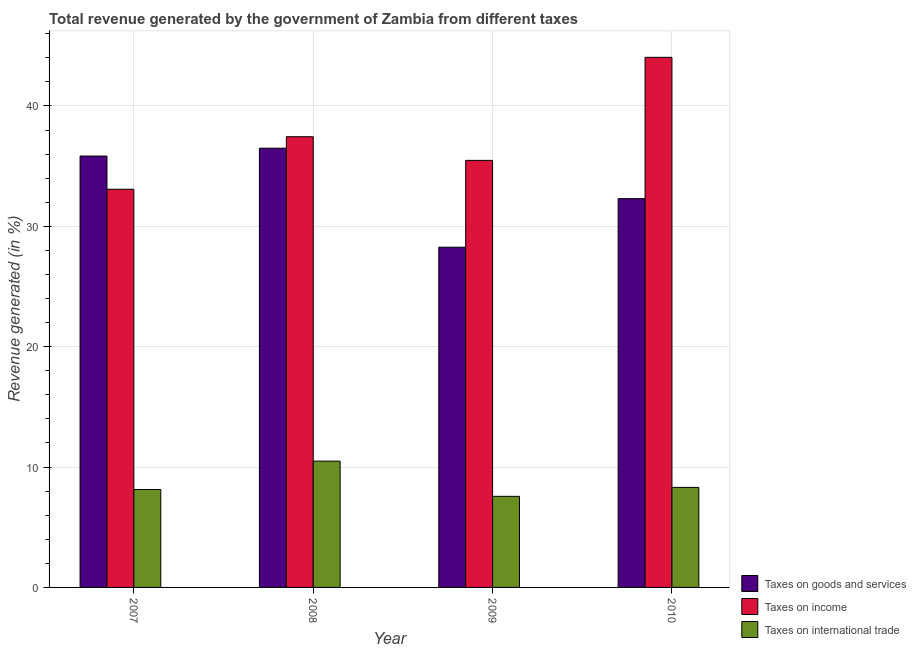How many different coloured bars are there?
Make the answer very short. 3. How many groups of bars are there?
Provide a short and direct response. 4. Are the number of bars on each tick of the X-axis equal?
Your answer should be compact. Yes. What is the label of the 2nd group of bars from the left?
Give a very brief answer. 2008. What is the percentage of revenue generated by taxes on income in 2009?
Offer a terse response. 35.48. Across all years, what is the maximum percentage of revenue generated by tax on international trade?
Offer a terse response. 10.49. Across all years, what is the minimum percentage of revenue generated by taxes on income?
Provide a succinct answer. 33.08. In which year was the percentage of revenue generated by taxes on goods and services maximum?
Your answer should be very brief. 2008. In which year was the percentage of revenue generated by tax on international trade minimum?
Your answer should be very brief. 2009. What is the total percentage of revenue generated by taxes on goods and services in the graph?
Provide a short and direct response. 132.9. What is the difference between the percentage of revenue generated by tax on international trade in 2007 and that in 2008?
Offer a terse response. -2.36. What is the difference between the percentage of revenue generated by tax on international trade in 2010 and the percentage of revenue generated by taxes on goods and services in 2009?
Give a very brief answer. 0.74. What is the average percentage of revenue generated by taxes on income per year?
Ensure brevity in your answer.  37.51. In the year 2009, what is the difference between the percentage of revenue generated by taxes on income and percentage of revenue generated by tax on international trade?
Make the answer very short. 0. In how many years, is the percentage of revenue generated by taxes on goods and services greater than 6 %?
Your answer should be very brief. 4. What is the ratio of the percentage of revenue generated by tax on international trade in 2007 to that in 2010?
Provide a short and direct response. 0.98. Is the percentage of revenue generated by taxes on income in 2008 less than that in 2010?
Your response must be concise. Yes. What is the difference between the highest and the second highest percentage of revenue generated by tax on international trade?
Keep it short and to the point. 2.18. What is the difference between the highest and the lowest percentage of revenue generated by taxes on income?
Ensure brevity in your answer.  10.96. What does the 1st bar from the left in 2009 represents?
Make the answer very short. Taxes on goods and services. What does the 1st bar from the right in 2010 represents?
Provide a short and direct response. Taxes on international trade. How many bars are there?
Provide a succinct answer. 12. How many years are there in the graph?
Your answer should be very brief. 4. What is the difference between two consecutive major ticks on the Y-axis?
Offer a very short reply. 10. Does the graph contain any zero values?
Offer a very short reply. No. How are the legend labels stacked?
Your answer should be very brief. Vertical. What is the title of the graph?
Ensure brevity in your answer.  Total revenue generated by the government of Zambia from different taxes. Does "Social Insurance" appear as one of the legend labels in the graph?
Ensure brevity in your answer.  No. What is the label or title of the X-axis?
Provide a short and direct response. Year. What is the label or title of the Y-axis?
Keep it short and to the point. Revenue generated (in %). What is the Revenue generated (in %) in Taxes on goods and services in 2007?
Ensure brevity in your answer.  35.84. What is the Revenue generated (in %) of Taxes on income in 2007?
Keep it short and to the point. 33.08. What is the Revenue generated (in %) of Taxes on international trade in 2007?
Provide a succinct answer. 8.14. What is the Revenue generated (in %) in Taxes on goods and services in 2008?
Your answer should be compact. 36.49. What is the Revenue generated (in %) of Taxes on income in 2008?
Make the answer very short. 37.45. What is the Revenue generated (in %) of Taxes on international trade in 2008?
Make the answer very short. 10.49. What is the Revenue generated (in %) of Taxes on goods and services in 2009?
Your answer should be compact. 28.27. What is the Revenue generated (in %) of Taxes on income in 2009?
Offer a very short reply. 35.48. What is the Revenue generated (in %) in Taxes on international trade in 2009?
Keep it short and to the point. 7.57. What is the Revenue generated (in %) of Taxes on goods and services in 2010?
Give a very brief answer. 32.3. What is the Revenue generated (in %) in Taxes on income in 2010?
Give a very brief answer. 44.04. What is the Revenue generated (in %) in Taxes on international trade in 2010?
Offer a very short reply. 8.31. Across all years, what is the maximum Revenue generated (in %) of Taxes on goods and services?
Your response must be concise. 36.49. Across all years, what is the maximum Revenue generated (in %) in Taxes on income?
Your response must be concise. 44.04. Across all years, what is the maximum Revenue generated (in %) in Taxes on international trade?
Your response must be concise. 10.49. Across all years, what is the minimum Revenue generated (in %) of Taxes on goods and services?
Keep it short and to the point. 28.27. Across all years, what is the minimum Revenue generated (in %) of Taxes on income?
Give a very brief answer. 33.08. Across all years, what is the minimum Revenue generated (in %) of Taxes on international trade?
Provide a succinct answer. 7.57. What is the total Revenue generated (in %) in Taxes on goods and services in the graph?
Keep it short and to the point. 132.9. What is the total Revenue generated (in %) in Taxes on income in the graph?
Your answer should be compact. 150.05. What is the total Revenue generated (in %) of Taxes on international trade in the graph?
Your answer should be very brief. 34.51. What is the difference between the Revenue generated (in %) in Taxes on goods and services in 2007 and that in 2008?
Your answer should be very brief. -0.65. What is the difference between the Revenue generated (in %) of Taxes on income in 2007 and that in 2008?
Provide a short and direct response. -4.37. What is the difference between the Revenue generated (in %) of Taxes on international trade in 2007 and that in 2008?
Provide a succinct answer. -2.36. What is the difference between the Revenue generated (in %) of Taxes on goods and services in 2007 and that in 2009?
Ensure brevity in your answer.  7.58. What is the difference between the Revenue generated (in %) of Taxes on income in 2007 and that in 2009?
Give a very brief answer. -2.4. What is the difference between the Revenue generated (in %) in Taxes on international trade in 2007 and that in 2009?
Provide a short and direct response. 0.57. What is the difference between the Revenue generated (in %) of Taxes on goods and services in 2007 and that in 2010?
Your answer should be very brief. 3.54. What is the difference between the Revenue generated (in %) in Taxes on income in 2007 and that in 2010?
Your response must be concise. -10.96. What is the difference between the Revenue generated (in %) in Taxes on international trade in 2007 and that in 2010?
Your answer should be very brief. -0.18. What is the difference between the Revenue generated (in %) in Taxes on goods and services in 2008 and that in 2009?
Provide a succinct answer. 8.23. What is the difference between the Revenue generated (in %) in Taxes on income in 2008 and that in 2009?
Give a very brief answer. 1.97. What is the difference between the Revenue generated (in %) in Taxes on international trade in 2008 and that in 2009?
Offer a terse response. 2.92. What is the difference between the Revenue generated (in %) of Taxes on goods and services in 2008 and that in 2010?
Ensure brevity in your answer.  4.19. What is the difference between the Revenue generated (in %) of Taxes on income in 2008 and that in 2010?
Make the answer very short. -6.6. What is the difference between the Revenue generated (in %) in Taxes on international trade in 2008 and that in 2010?
Offer a terse response. 2.18. What is the difference between the Revenue generated (in %) in Taxes on goods and services in 2009 and that in 2010?
Ensure brevity in your answer.  -4.04. What is the difference between the Revenue generated (in %) of Taxes on income in 2009 and that in 2010?
Your answer should be compact. -8.56. What is the difference between the Revenue generated (in %) of Taxes on international trade in 2009 and that in 2010?
Your response must be concise. -0.74. What is the difference between the Revenue generated (in %) of Taxes on goods and services in 2007 and the Revenue generated (in %) of Taxes on income in 2008?
Your response must be concise. -1.61. What is the difference between the Revenue generated (in %) of Taxes on goods and services in 2007 and the Revenue generated (in %) of Taxes on international trade in 2008?
Ensure brevity in your answer.  25.35. What is the difference between the Revenue generated (in %) in Taxes on income in 2007 and the Revenue generated (in %) in Taxes on international trade in 2008?
Make the answer very short. 22.59. What is the difference between the Revenue generated (in %) in Taxes on goods and services in 2007 and the Revenue generated (in %) in Taxes on income in 2009?
Provide a succinct answer. 0.36. What is the difference between the Revenue generated (in %) in Taxes on goods and services in 2007 and the Revenue generated (in %) in Taxes on international trade in 2009?
Make the answer very short. 28.27. What is the difference between the Revenue generated (in %) of Taxes on income in 2007 and the Revenue generated (in %) of Taxes on international trade in 2009?
Your response must be concise. 25.51. What is the difference between the Revenue generated (in %) of Taxes on goods and services in 2007 and the Revenue generated (in %) of Taxes on income in 2010?
Keep it short and to the point. -8.2. What is the difference between the Revenue generated (in %) of Taxes on goods and services in 2007 and the Revenue generated (in %) of Taxes on international trade in 2010?
Offer a terse response. 27.53. What is the difference between the Revenue generated (in %) in Taxes on income in 2007 and the Revenue generated (in %) in Taxes on international trade in 2010?
Your answer should be compact. 24.77. What is the difference between the Revenue generated (in %) in Taxes on goods and services in 2008 and the Revenue generated (in %) in Taxes on income in 2009?
Offer a terse response. 1.01. What is the difference between the Revenue generated (in %) in Taxes on goods and services in 2008 and the Revenue generated (in %) in Taxes on international trade in 2009?
Your response must be concise. 28.93. What is the difference between the Revenue generated (in %) in Taxes on income in 2008 and the Revenue generated (in %) in Taxes on international trade in 2009?
Your answer should be very brief. 29.88. What is the difference between the Revenue generated (in %) in Taxes on goods and services in 2008 and the Revenue generated (in %) in Taxes on income in 2010?
Provide a succinct answer. -7.55. What is the difference between the Revenue generated (in %) of Taxes on goods and services in 2008 and the Revenue generated (in %) of Taxes on international trade in 2010?
Give a very brief answer. 28.18. What is the difference between the Revenue generated (in %) in Taxes on income in 2008 and the Revenue generated (in %) in Taxes on international trade in 2010?
Your answer should be compact. 29.13. What is the difference between the Revenue generated (in %) of Taxes on goods and services in 2009 and the Revenue generated (in %) of Taxes on income in 2010?
Provide a short and direct response. -15.78. What is the difference between the Revenue generated (in %) in Taxes on goods and services in 2009 and the Revenue generated (in %) in Taxes on international trade in 2010?
Give a very brief answer. 19.95. What is the difference between the Revenue generated (in %) in Taxes on income in 2009 and the Revenue generated (in %) in Taxes on international trade in 2010?
Make the answer very short. 27.17. What is the average Revenue generated (in %) of Taxes on goods and services per year?
Give a very brief answer. 33.23. What is the average Revenue generated (in %) of Taxes on income per year?
Offer a very short reply. 37.51. What is the average Revenue generated (in %) in Taxes on international trade per year?
Keep it short and to the point. 8.63. In the year 2007, what is the difference between the Revenue generated (in %) in Taxes on goods and services and Revenue generated (in %) in Taxes on income?
Keep it short and to the point. 2.76. In the year 2007, what is the difference between the Revenue generated (in %) of Taxes on goods and services and Revenue generated (in %) of Taxes on international trade?
Your answer should be compact. 27.7. In the year 2007, what is the difference between the Revenue generated (in %) of Taxes on income and Revenue generated (in %) of Taxes on international trade?
Your answer should be very brief. 24.94. In the year 2008, what is the difference between the Revenue generated (in %) of Taxes on goods and services and Revenue generated (in %) of Taxes on income?
Provide a short and direct response. -0.95. In the year 2008, what is the difference between the Revenue generated (in %) of Taxes on goods and services and Revenue generated (in %) of Taxes on international trade?
Your response must be concise. 26. In the year 2008, what is the difference between the Revenue generated (in %) in Taxes on income and Revenue generated (in %) in Taxes on international trade?
Offer a very short reply. 26.95. In the year 2009, what is the difference between the Revenue generated (in %) in Taxes on goods and services and Revenue generated (in %) in Taxes on income?
Provide a succinct answer. -7.21. In the year 2009, what is the difference between the Revenue generated (in %) of Taxes on goods and services and Revenue generated (in %) of Taxes on international trade?
Your response must be concise. 20.7. In the year 2009, what is the difference between the Revenue generated (in %) of Taxes on income and Revenue generated (in %) of Taxes on international trade?
Your answer should be very brief. 27.91. In the year 2010, what is the difference between the Revenue generated (in %) in Taxes on goods and services and Revenue generated (in %) in Taxes on income?
Make the answer very short. -11.74. In the year 2010, what is the difference between the Revenue generated (in %) in Taxes on goods and services and Revenue generated (in %) in Taxes on international trade?
Your answer should be very brief. 23.99. In the year 2010, what is the difference between the Revenue generated (in %) in Taxes on income and Revenue generated (in %) in Taxes on international trade?
Your response must be concise. 35.73. What is the ratio of the Revenue generated (in %) in Taxes on goods and services in 2007 to that in 2008?
Your response must be concise. 0.98. What is the ratio of the Revenue generated (in %) of Taxes on income in 2007 to that in 2008?
Provide a succinct answer. 0.88. What is the ratio of the Revenue generated (in %) of Taxes on international trade in 2007 to that in 2008?
Keep it short and to the point. 0.78. What is the ratio of the Revenue generated (in %) in Taxes on goods and services in 2007 to that in 2009?
Ensure brevity in your answer.  1.27. What is the ratio of the Revenue generated (in %) of Taxes on income in 2007 to that in 2009?
Provide a short and direct response. 0.93. What is the ratio of the Revenue generated (in %) in Taxes on international trade in 2007 to that in 2009?
Keep it short and to the point. 1.07. What is the ratio of the Revenue generated (in %) in Taxes on goods and services in 2007 to that in 2010?
Provide a succinct answer. 1.11. What is the ratio of the Revenue generated (in %) in Taxes on income in 2007 to that in 2010?
Ensure brevity in your answer.  0.75. What is the ratio of the Revenue generated (in %) in Taxes on international trade in 2007 to that in 2010?
Offer a terse response. 0.98. What is the ratio of the Revenue generated (in %) in Taxes on goods and services in 2008 to that in 2009?
Your answer should be compact. 1.29. What is the ratio of the Revenue generated (in %) of Taxes on income in 2008 to that in 2009?
Your answer should be compact. 1.06. What is the ratio of the Revenue generated (in %) in Taxes on international trade in 2008 to that in 2009?
Ensure brevity in your answer.  1.39. What is the ratio of the Revenue generated (in %) in Taxes on goods and services in 2008 to that in 2010?
Your answer should be compact. 1.13. What is the ratio of the Revenue generated (in %) of Taxes on income in 2008 to that in 2010?
Offer a very short reply. 0.85. What is the ratio of the Revenue generated (in %) in Taxes on international trade in 2008 to that in 2010?
Provide a short and direct response. 1.26. What is the ratio of the Revenue generated (in %) in Taxes on goods and services in 2009 to that in 2010?
Provide a short and direct response. 0.88. What is the ratio of the Revenue generated (in %) of Taxes on income in 2009 to that in 2010?
Offer a very short reply. 0.81. What is the ratio of the Revenue generated (in %) of Taxes on international trade in 2009 to that in 2010?
Ensure brevity in your answer.  0.91. What is the difference between the highest and the second highest Revenue generated (in %) of Taxes on goods and services?
Offer a very short reply. 0.65. What is the difference between the highest and the second highest Revenue generated (in %) in Taxes on income?
Your answer should be compact. 6.6. What is the difference between the highest and the second highest Revenue generated (in %) in Taxes on international trade?
Provide a short and direct response. 2.18. What is the difference between the highest and the lowest Revenue generated (in %) of Taxes on goods and services?
Your response must be concise. 8.23. What is the difference between the highest and the lowest Revenue generated (in %) of Taxes on income?
Provide a short and direct response. 10.96. What is the difference between the highest and the lowest Revenue generated (in %) in Taxes on international trade?
Your answer should be very brief. 2.92. 